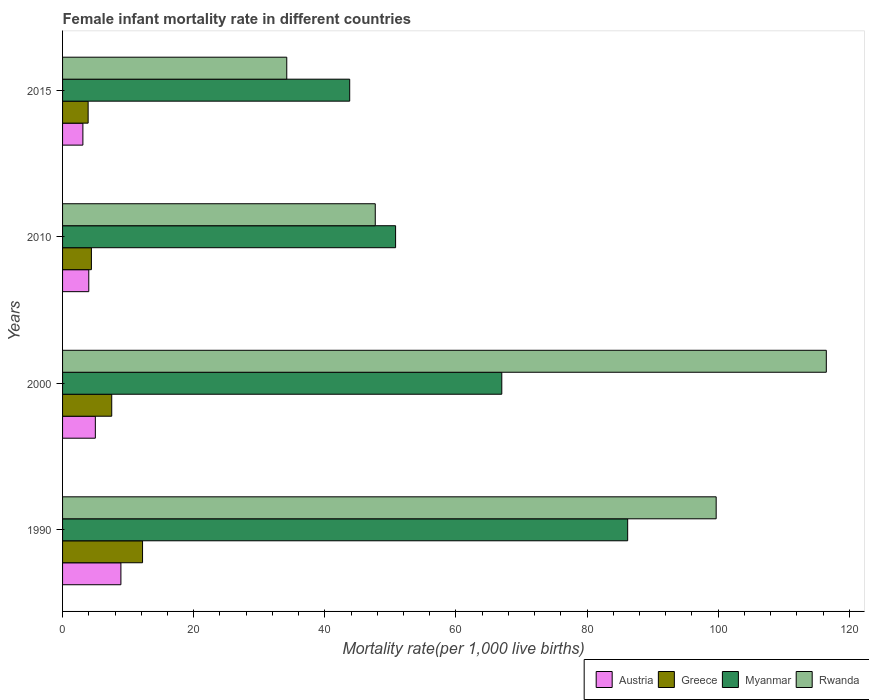How many different coloured bars are there?
Provide a short and direct response. 4. How many bars are there on the 1st tick from the top?
Your answer should be very brief. 4. How many bars are there on the 1st tick from the bottom?
Provide a short and direct response. 4. What is the label of the 1st group of bars from the top?
Ensure brevity in your answer.  2015. In how many cases, is the number of bars for a given year not equal to the number of legend labels?
Offer a terse response. 0. What is the female infant mortality rate in Austria in 2010?
Ensure brevity in your answer.  4. Across all years, what is the maximum female infant mortality rate in Rwanda?
Provide a succinct answer. 116.5. Across all years, what is the minimum female infant mortality rate in Myanmar?
Your answer should be very brief. 43.8. In which year was the female infant mortality rate in Rwanda minimum?
Keep it short and to the point. 2015. What is the difference between the female infant mortality rate in Austria in 1990 and the female infant mortality rate in Rwanda in 2000?
Your answer should be very brief. -107.6. What is the average female infant mortality rate in Rwanda per year?
Give a very brief answer. 74.52. In the year 2010, what is the difference between the female infant mortality rate in Rwanda and female infant mortality rate in Myanmar?
Give a very brief answer. -3.1. In how many years, is the female infant mortality rate in Rwanda greater than 32 ?
Provide a succinct answer. 4. What is the ratio of the female infant mortality rate in Greece in 1990 to that in 2000?
Your answer should be compact. 1.63. Is the female infant mortality rate in Myanmar in 2000 less than that in 2015?
Offer a very short reply. No. What is the difference between the highest and the second highest female infant mortality rate in Rwanda?
Give a very brief answer. 16.8. What is the difference between the highest and the lowest female infant mortality rate in Rwanda?
Your response must be concise. 82.3. In how many years, is the female infant mortality rate in Austria greater than the average female infant mortality rate in Austria taken over all years?
Your answer should be very brief. 1. Is the sum of the female infant mortality rate in Myanmar in 2000 and 2015 greater than the maximum female infant mortality rate in Austria across all years?
Give a very brief answer. Yes. What does the 1st bar from the top in 2010 represents?
Your answer should be compact. Rwanda. What does the 3rd bar from the bottom in 2010 represents?
Your answer should be compact. Myanmar. How many bars are there?
Offer a very short reply. 16. Are all the bars in the graph horizontal?
Provide a short and direct response. Yes. How many years are there in the graph?
Make the answer very short. 4. What is the difference between two consecutive major ticks on the X-axis?
Keep it short and to the point. 20. How many legend labels are there?
Keep it short and to the point. 4. How are the legend labels stacked?
Ensure brevity in your answer.  Horizontal. What is the title of the graph?
Provide a short and direct response. Female infant mortality rate in different countries. Does "Qatar" appear as one of the legend labels in the graph?
Offer a terse response. No. What is the label or title of the X-axis?
Give a very brief answer. Mortality rate(per 1,0 live births). What is the label or title of the Y-axis?
Make the answer very short. Years. What is the Mortality rate(per 1,000 live births) of Austria in 1990?
Your response must be concise. 8.9. What is the Mortality rate(per 1,000 live births) of Greece in 1990?
Keep it short and to the point. 12.2. What is the Mortality rate(per 1,000 live births) of Myanmar in 1990?
Your response must be concise. 86.2. What is the Mortality rate(per 1,000 live births) in Rwanda in 1990?
Keep it short and to the point. 99.7. What is the Mortality rate(per 1,000 live births) in Austria in 2000?
Your answer should be very brief. 5. What is the Mortality rate(per 1,000 live births) in Greece in 2000?
Provide a short and direct response. 7.5. What is the Mortality rate(per 1,000 live births) in Myanmar in 2000?
Your response must be concise. 67. What is the Mortality rate(per 1,000 live births) in Rwanda in 2000?
Keep it short and to the point. 116.5. What is the Mortality rate(per 1,000 live births) in Myanmar in 2010?
Your response must be concise. 50.8. What is the Mortality rate(per 1,000 live births) of Rwanda in 2010?
Ensure brevity in your answer.  47.7. What is the Mortality rate(per 1,000 live births) of Austria in 2015?
Provide a succinct answer. 3.1. What is the Mortality rate(per 1,000 live births) in Greece in 2015?
Your answer should be very brief. 3.9. What is the Mortality rate(per 1,000 live births) of Myanmar in 2015?
Keep it short and to the point. 43.8. What is the Mortality rate(per 1,000 live births) in Rwanda in 2015?
Offer a terse response. 34.2. Across all years, what is the maximum Mortality rate(per 1,000 live births) of Greece?
Keep it short and to the point. 12.2. Across all years, what is the maximum Mortality rate(per 1,000 live births) in Myanmar?
Offer a very short reply. 86.2. Across all years, what is the maximum Mortality rate(per 1,000 live births) in Rwanda?
Your answer should be compact. 116.5. Across all years, what is the minimum Mortality rate(per 1,000 live births) of Austria?
Give a very brief answer. 3.1. Across all years, what is the minimum Mortality rate(per 1,000 live births) of Greece?
Your response must be concise. 3.9. Across all years, what is the minimum Mortality rate(per 1,000 live births) in Myanmar?
Provide a short and direct response. 43.8. Across all years, what is the minimum Mortality rate(per 1,000 live births) in Rwanda?
Your answer should be compact. 34.2. What is the total Mortality rate(per 1,000 live births) of Austria in the graph?
Make the answer very short. 21. What is the total Mortality rate(per 1,000 live births) of Myanmar in the graph?
Offer a very short reply. 247.8. What is the total Mortality rate(per 1,000 live births) of Rwanda in the graph?
Your response must be concise. 298.1. What is the difference between the Mortality rate(per 1,000 live births) in Austria in 1990 and that in 2000?
Offer a very short reply. 3.9. What is the difference between the Mortality rate(per 1,000 live births) of Greece in 1990 and that in 2000?
Provide a short and direct response. 4.7. What is the difference between the Mortality rate(per 1,000 live births) of Myanmar in 1990 and that in 2000?
Provide a short and direct response. 19.2. What is the difference between the Mortality rate(per 1,000 live births) of Rwanda in 1990 and that in 2000?
Your response must be concise. -16.8. What is the difference between the Mortality rate(per 1,000 live births) of Myanmar in 1990 and that in 2010?
Your answer should be very brief. 35.4. What is the difference between the Mortality rate(per 1,000 live births) of Rwanda in 1990 and that in 2010?
Your response must be concise. 52. What is the difference between the Mortality rate(per 1,000 live births) in Austria in 1990 and that in 2015?
Provide a succinct answer. 5.8. What is the difference between the Mortality rate(per 1,000 live births) of Myanmar in 1990 and that in 2015?
Keep it short and to the point. 42.4. What is the difference between the Mortality rate(per 1,000 live births) of Rwanda in 1990 and that in 2015?
Ensure brevity in your answer.  65.5. What is the difference between the Mortality rate(per 1,000 live births) of Greece in 2000 and that in 2010?
Your answer should be compact. 3.1. What is the difference between the Mortality rate(per 1,000 live births) in Myanmar in 2000 and that in 2010?
Your response must be concise. 16.2. What is the difference between the Mortality rate(per 1,000 live births) of Rwanda in 2000 and that in 2010?
Give a very brief answer. 68.8. What is the difference between the Mortality rate(per 1,000 live births) in Austria in 2000 and that in 2015?
Your answer should be very brief. 1.9. What is the difference between the Mortality rate(per 1,000 live births) in Myanmar in 2000 and that in 2015?
Your answer should be compact. 23.2. What is the difference between the Mortality rate(per 1,000 live births) in Rwanda in 2000 and that in 2015?
Offer a very short reply. 82.3. What is the difference between the Mortality rate(per 1,000 live births) of Austria in 2010 and that in 2015?
Offer a very short reply. 0.9. What is the difference between the Mortality rate(per 1,000 live births) in Myanmar in 2010 and that in 2015?
Offer a very short reply. 7. What is the difference between the Mortality rate(per 1,000 live births) of Austria in 1990 and the Mortality rate(per 1,000 live births) of Myanmar in 2000?
Your response must be concise. -58.1. What is the difference between the Mortality rate(per 1,000 live births) of Austria in 1990 and the Mortality rate(per 1,000 live births) of Rwanda in 2000?
Make the answer very short. -107.6. What is the difference between the Mortality rate(per 1,000 live births) of Greece in 1990 and the Mortality rate(per 1,000 live births) of Myanmar in 2000?
Your answer should be compact. -54.8. What is the difference between the Mortality rate(per 1,000 live births) in Greece in 1990 and the Mortality rate(per 1,000 live births) in Rwanda in 2000?
Provide a succinct answer. -104.3. What is the difference between the Mortality rate(per 1,000 live births) in Myanmar in 1990 and the Mortality rate(per 1,000 live births) in Rwanda in 2000?
Offer a very short reply. -30.3. What is the difference between the Mortality rate(per 1,000 live births) in Austria in 1990 and the Mortality rate(per 1,000 live births) in Myanmar in 2010?
Your answer should be compact. -41.9. What is the difference between the Mortality rate(per 1,000 live births) of Austria in 1990 and the Mortality rate(per 1,000 live births) of Rwanda in 2010?
Offer a terse response. -38.8. What is the difference between the Mortality rate(per 1,000 live births) of Greece in 1990 and the Mortality rate(per 1,000 live births) of Myanmar in 2010?
Provide a succinct answer. -38.6. What is the difference between the Mortality rate(per 1,000 live births) in Greece in 1990 and the Mortality rate(per 1,000 live births) in Rwanda in 2010?
Keep it short and to the point. -35.5. What is the difference between the Mortality rate(per 1,000 live births) of Myanmar in 1990 and the Mortality rate(per 1,000 live births) of Rwanda in 2010?
Your answer should be very brief. 38.5. What is the difference between the Mortality rate(per 1,000 live births) in Austria in 1990 and the Mortality rate(per 1,000 live births) in Myanmar in 2015?
Make the answer very short. -34.9. What is the difference between the Mortality rate(per 1,000 live births) of Austria in 1990 and the Mortality rate(per 1,000 live births) of Rwanda in 2015?
Provide a succinct answer. -25.3. What is the difference between the Mortality rate(per 1,000 live births) of Greece in 1990 and the Mortality rate(per 1,000 live births) of Myanmar in 2015?
Your response must be concise. -31.6. What is the difference between the Mortality rate(per 1,000 live births) in Austria in 2000 and the Mortality rate(per 1,000 live births) in Myanmar in 2010?
Provide a short and direct response. -45.8. What is the difference between the Mortality rate(per 1,000 live births) in Austria in 2000 and the Mortality rate(per 1,000 live births) in Rwanda in 2010?
Your answer should be compact. -42.7. What is the difference between the Mortality rate(per 1,000 live births) in Greece in 2000 and the Mortality rate(per 1,000 live births) in Myanmar in 2010?
Your answer should be compact. -43.3. What is the difference between the Mortality rate(per 1,000 live births) of Greece in 2000 and the Mortality rate(per 1,000 live births) of Rwanda in 2010?
Give a very brief answer. -40.2. What is the difference between the Mortality rate(per 1,000 live births) in Myanmar in 2000 and the Mortality rate(per 1,000 live births) in Rwanda in 2010?
Offer a terse response. 19.3. What is the difference between the Mortality rate(per 1,000 live births) in Austria in 2000 and the Mortality rate(per 1,000 live births) in Myanmar in 2015?
Your answer should be very brief. -38.8. What is the difference between the Mortality rate(per 1,000 live births) of Austria in 2000 and the Mortality rate(per 1,000 live births) of Rwanda in 2015?
Your response must be concise. -29.2. What is the difference between the Mortality rate(per 1,000 live births) in Greece in 2000 and the Mortality rate(per 1,000 live births) in Myanmar in 2015?
Offer a very short reply. -36.3. What is the difference between the Mortality rate(per 1,000 live births) in Greece in 2000 and the Mortality rate(per 1,000 live births) in Rwanda in 2015?
Your response must be concise. -26.7. What is the difference between the Mortality rate(per 1,000 live births) of Myanmar in 2000 and the Mortality rate(per 1,000 live births) of Rwanda in 2015?
Offer a very short reply. 32.8. What is the difference between the Mortality rate(per 1,000 live births) in Austria in 2010 and the Mortality rate(per 1,000 live births) in Myanmar in 2015?
Keep it short and to the point. -39.8. What is the difference between the Mortality rate(per 1,000 live births) of Austria in 2010 and the Mortality rate(per 1,000 live births) of Rwanda in 2015?
Provide a short and direct response. -30.2. What is the difference between the Mortality rate(per 1,000 live births) in Greece in 2010 and the Mortality rate(per 1,000 live births) in Myanmar in 2015?
Offer a terse response. -39.4. What is the difference between the Mortality rate(per 1,000 live births) in Greece in 2010 and the Mortality rate(per 1,000 live births) in Rwanda in 2015?
Your response must be concise. -29.8. What is the difference between the Mortality rate(per 1,000 live births) in Myanmar in 2010 and the Mortality rate(per 1,000 live births) in Rwanda in 2015?
Your answer should be compact. 16.6. What is the average Mortality rate(per 1,000 live births) of Austria per year?
Provide a succinct answer. 5.25. What is the average Mortality rate(per 1,000 live births) in Greece per year?
Ensure brevity in your answer.  7. What is the average Mortality rate(per 1,000 live births) in Myanmar per year?
Offer a very short reply. 61.95. What is the average Mortality rate(per 1,000 live births) of Rwanda per year?
Offer a terse response. 74.53. In the year 1990, what is the difference between the Mortality rate(per 1,000 live births) in Austria and Mortality rate(per 1,000 live births) in Myanmar?
Your response must be concise. -77.3. In the year 1990, what is the difference between the Mortality rate(per 1,000 live births) in Austria and Mortality rate(per 1,000 live births) in Rwanda?
Keep it short and to the point. -90.8. In the year 1990, what is the difference between the Mortality rate(per 1,000 live births) of Greece and Mortality rate(per 1,000 live births) of Myanmar?
Offer a very short reply. -74. In the year 1990, what is the difference between the Mortality rate(per 1,000 live births) in Greece and Mortality rate(per 1,000 live births) in Rwanda?
Make the answer very short. -87.5. In the year 2000, what is the difference between the Mortality rate(per 1,000 live births) of Austria and Mortality rate(per 1,000 live births) of Myanmar?
Give a very brief answer. -62. In the year 2000, what is the difference between the Mortality rate(per 1,000 live births) in Austria and Mortality rate(per 1,000 live births) in Rwanda?
Give a very brief answer. -111.5. In the year 2000, what is the difference between the Mortality rate(per 1,000 live births) of Greece and Mortality rate(per 1,000 live births) of Myanmar?
Offer a terse response. -59.5. In the year 2000, what is the difference between the Mortality rate(per 1,000 live births) of Greece and Mortality rate(per 1,000 live births) of Rwanda?
Your answer should be very brief. -109. In the year 2000, what is the difference between the Mortality rate(per 1,000 live births) in Myanmar and Mortality rate(per 1,000 live births) in Rwanda?
Make the answer very short. -49.5. In the year 2010, what is the difference between the Mortality rate(per 1,000 live births) in Austria and Mortality rate(per 1,000 live births) in Myanmar?
Provide a short and direct response. -46.8. In the year 2010, what is the difference between the Mortality rate(per 1,000 live births) in Austria and Mortality rate(per 1,000 live births) in Rwanda?
Keep it short and to the point. -43.7. In the year 2010, what is the difference between the Mortality rate(per 1,000 live births) in Greece and Mortality rate(per 1,000 live births) in Myanmar?
Provide a short and direct response. -46.4. In the year 2010, what is the difference between the Mortality rate(per 1,000 live births) of Greece and Mortality rate(per 1,000 live births) of Rwanda?
Offer a very short reply. -43.3. In the year 2010, what is the difference between the Mortality rate(per 1,000 live births) of Myanmar and Mortality rate(per 1,000 live births) of Rwanda?
Provide a succinct answer. 3.1. In the year 2015, what is the difference between the Mortality rate(per 1,000 live births) in Austria and Mortality rate(per 1,000 live births) in Myanmar?
Ensure brevity in your answer.  -40.7. In the year 2015, what is the difference between the Mortality rate(per 1,000 live births) in Austria and Mortality rate(per 1,000 live births) in Rwanda?
Your response must be concise. -31.1. In the year 2015, what is the difference between the Mortality rate(per 1,000 live births) in Greece and Mortality rate(per 1,000 live births) in Myanmar?
Provide a short and direct response. -39.9. In the year 2015, what is the difference between the Mortality rate(per 1,000 live births) of Greece and Mortality rate(per 1,000 live births) of Rwanda?
Offer a terse response. -30.3. What is the ratio of the Mortality rate(per 1,000 live births) of Austria in 1990 to that in 2000?
Offer a very short reply. 1.78. What is the ratio of the Mortality rate(per 1,000 live births) in Greece in 1990 to that in 2000?
Your answer should be compact. 1.63. What is the ratio of the Mortality rate(per 1,000 live births) in Myanmar in 1990 to that in 2000?
Make the answer very short. 1.29. What is the ratio of the Mortality rate(per 1,000 live births) of Rwanda in 1990 to that in 2000?
Make the answer very short. 0.86. What is the ratio of the Mortality rate(per 1,000 live births) of Austria in 1990 to that in 2010?
Your answer should be compact. 2.23. What is the ratio of the Mortality rate(per 1,000 live births) in Greece in 1990 to that in 2010?
Give a very brief answer. 2.77. What is the ratio of the Mortality rate(per 1,000 live births) of Myanmar in 1990 to that in 2010?
Give a very brief answer. 1.7. What is the ratio of the Mortality rate(per 1,000 live births) in Rwanda in 1990 to that in 2010?
Give a very brief answer. 2.09. What is the ratio of the Mortality rate(per 1,000 live births) in Austria in 1990 to that in 2015?
Make the answer very short. 2.87. What is the ratio of the Mortality rate(per 1,000 live births) in Greece in 1990 to that in 2015?
Your answer should be very brief. 3.13. What is the ratio of the Mortality rate(per 1,000 live births) of Myanmar in 1990 to that in 2015?
Offer a terse response. 1.97. What is the ratio of the Mortality rate(per 1,000 live births) in Rwanda in 1990 to that in 2015?
Ensure brevity in your answer.  2.92. What is the ratio of the Mortality rate(per 1,000 live births) of Greece in 2000 to that in 2010?
Provide a short and direct response. 1.7. What is the ratio of the Mortality rate(per 1,000 live births) in Myanmar in 2000 to that in 2010?
Give a very brief answer. 1.32. What is the ratio of the Mortality rate(per 1,000 live births) of Rwanda in 2000 to that in 2010?
Give a very brief answer. 2.44. What is the ratio of the Mortality rate(per 1,000 live births) in Austria in 2000 to that in 2015?
Provide a succinct answer. 1.61. What is the ratio of the Mortality rate(per 1,000 live births) in Greece in 2000 to that in 2015?
Make the answer very short. 1.92. What is the ratio of the Mortality rate(per 1,000 live births) in Myanmar in 2000 to that in 2015?
Your response must be concise. 1.53. What is the ratio of the Mortality rate(per 1,000 live births) in Rwanda in 2000 to that in 2015?
Your answer should be compact. 3.41. What is the ratio of the Mortality rate(per 1,000 live births) of Austria in 2010 to that in 2015?
Provide a short and direct response. 1.29. What is the ratio of the Mortality rate(per 1,000 live births) in Greece in 2010 to that in 2015?
Your response must be concise. 1.13. What is the ratio of the Mortality rate(per 1,000 live births) of Myanmar in 2010 to that in 2015?
Offer a terse response. 1.16. What is the ratio of the Mortality rate(per 1,000 live births) in Rwanda in 2010 to that in 2015?
Make the answer very short. 1.39. What is the difference between the highest and the second highest Mortality rate(per 1,000 live births) of Austria?
Provide a short and direct response. 3.9. What is the difference between the highest and the second highest Mortality rate(per 1,000 live births) in Greece?
Keep it short and to the point. 4.7. What is the difference between the highest and the lowest Mortality rate(per 1,000 live births) of Austria?
Keep it short and to the point. 5.8. What is the difference between the highest and the lowest Mortality rate(per 1,000 live births) in Myanmar?
Offer a terse response. 42.4. What is the difference between the highest and the lowest Mortality rate(per 1,000 live births) in Rwanda?
Provide a succinct answer. 82.3. 